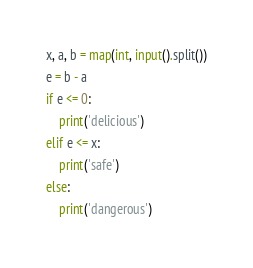<code> <loc_0><loc_0><loc_500><loc_500><_Python_>x, a, b = map(int, input().split())
e = b - a
if e <= 0:
    print('delicious')
elif e <= x:
    print('safe')
else:
    print('dangerous')</code> 